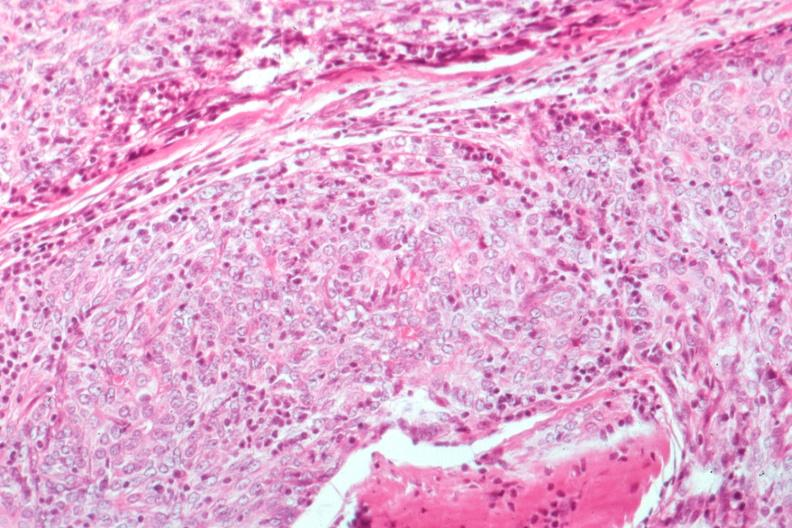s thymoma present?
Answer the question using a single word or phrase. Yes 